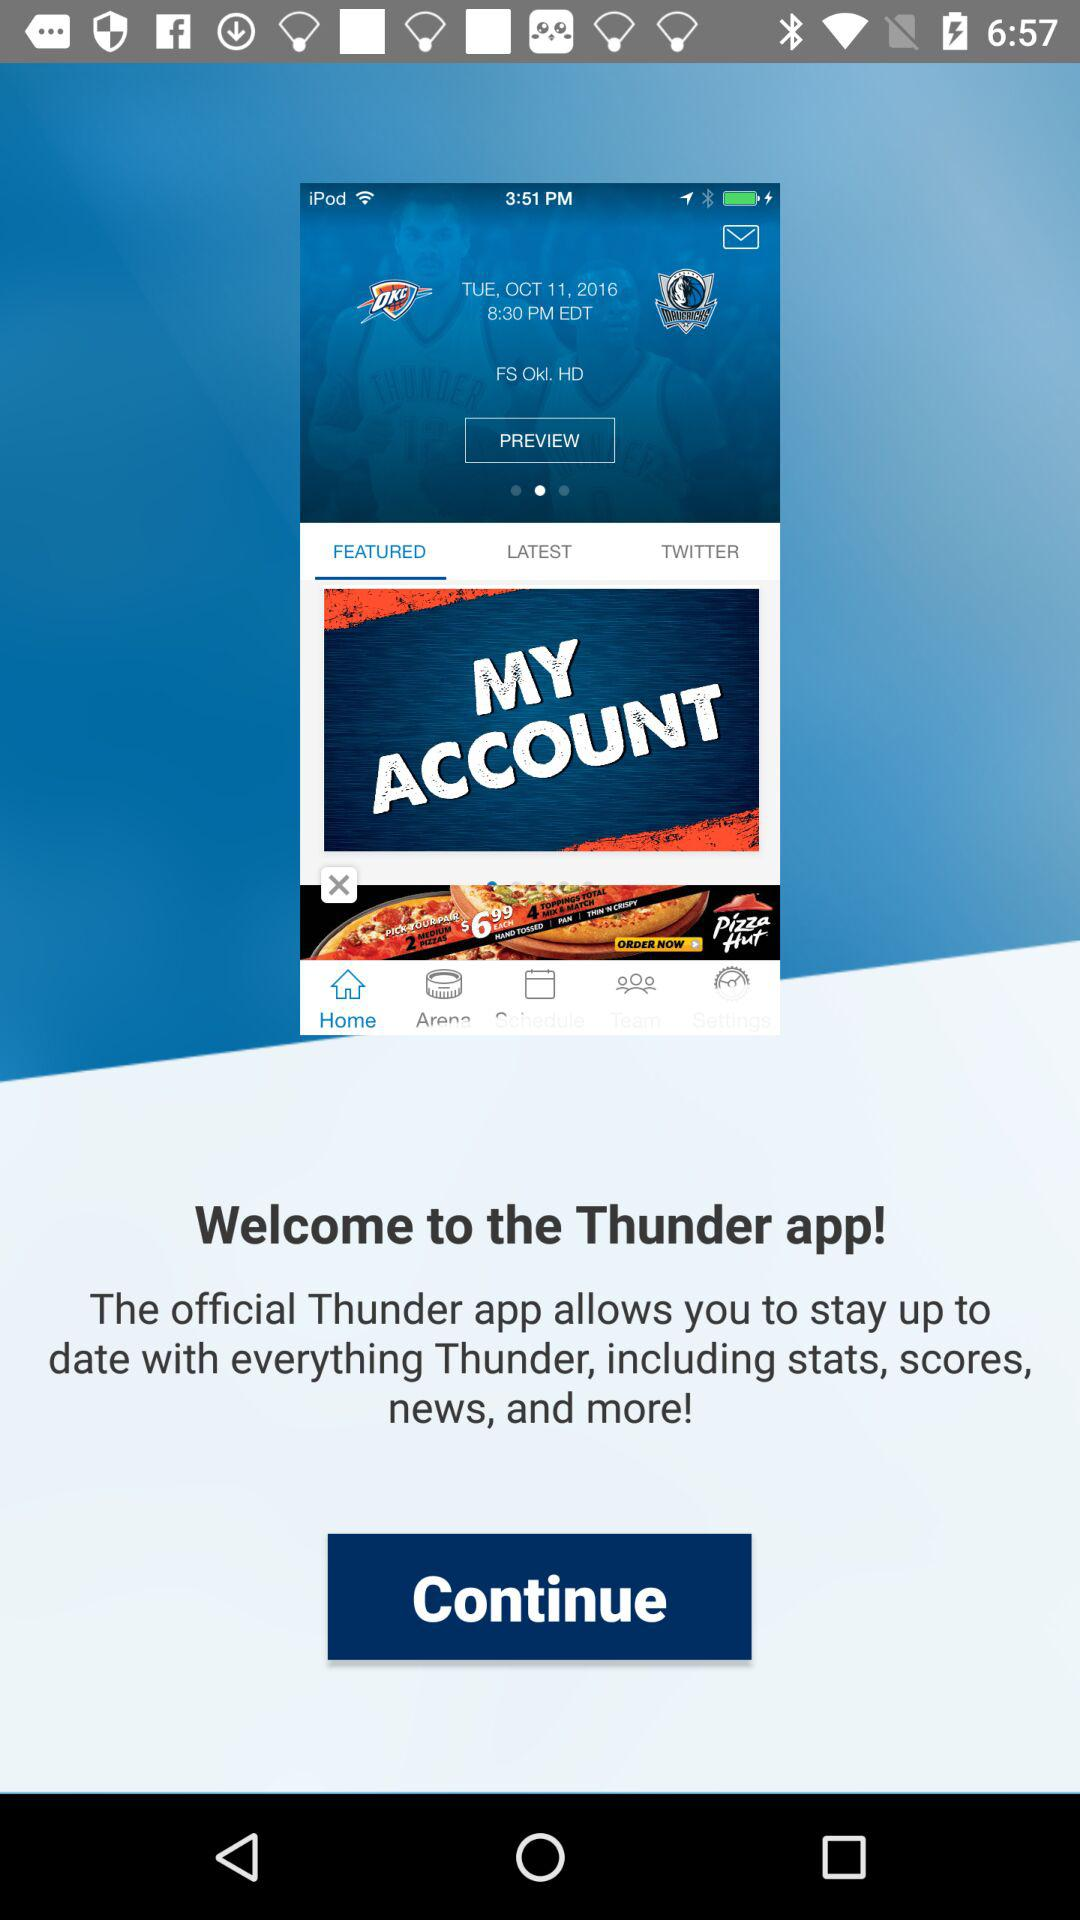What is the application name? The application name is "Thunder". 